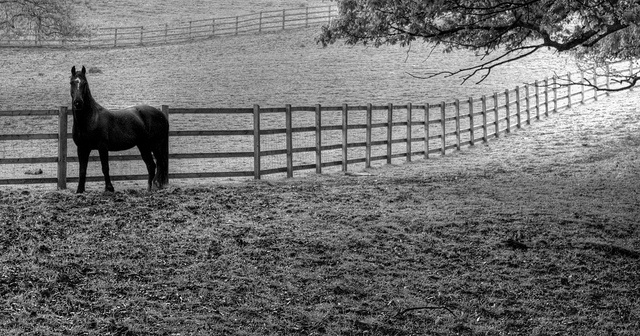Describe the objects in this image and their specific colors. I can see a horse in gray, black, and lightgray tones in this image. 